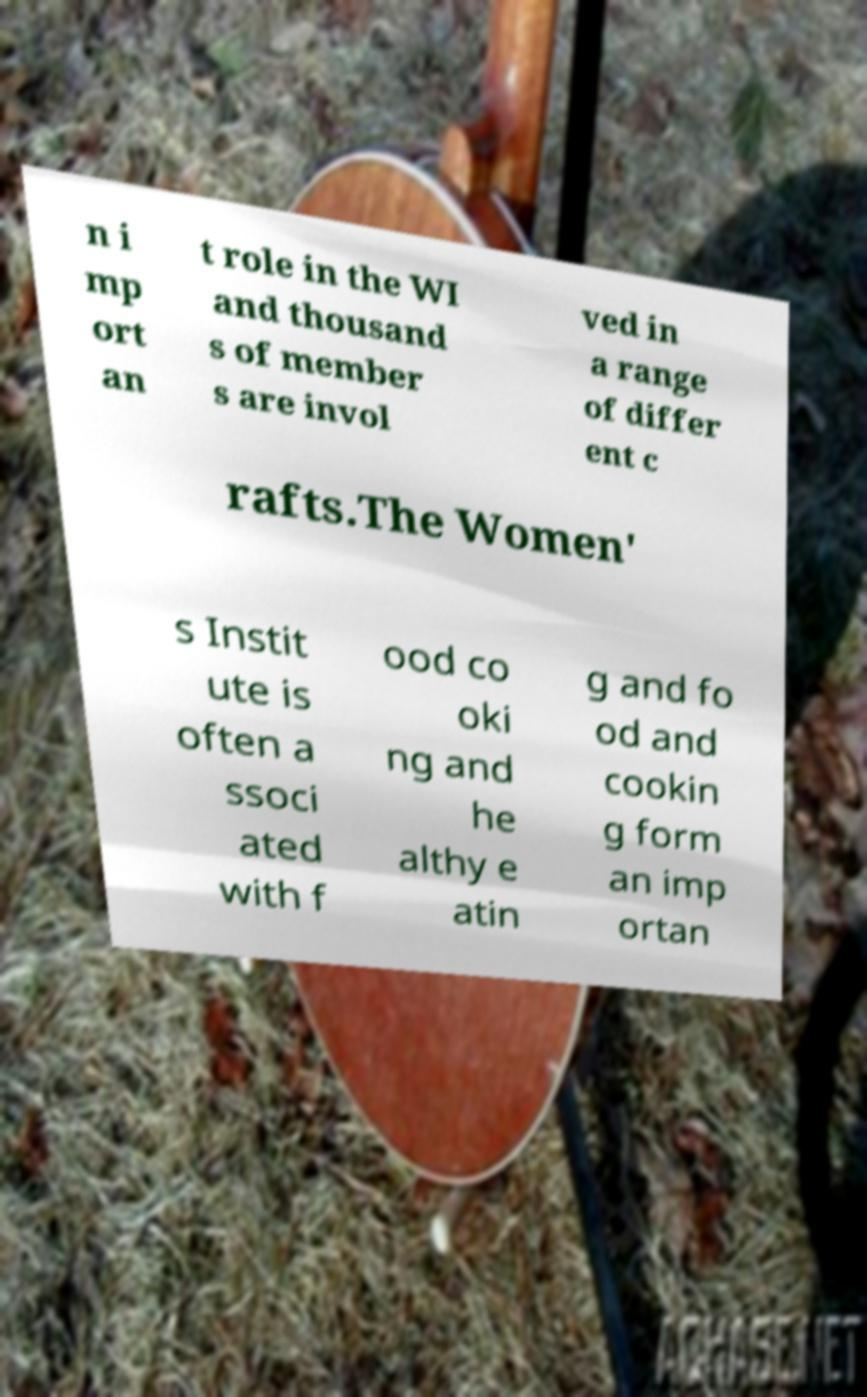Please read and relay the text visible in this image. What does it say? n i mp ort an t role in the WI and thousand s of member s are invol ved in a range of differ ent c rafts.The Women' s Instit ute is often a ssoci ated with f ood co oki ng and he althy e atin g and fo od and cookin g form an imp ortan 